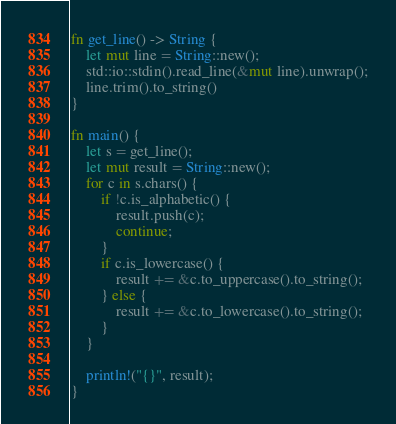Convert code to text. <code><loc_0><loc_0><loc_500><loc_500><_Rust_>fn get_line() -> String {
    let mut line = String::new();
    std::io::stdin().read_line(&mut line).unwrap();
    line.trim().to_string()
}

fn main() {
    let s = get_line();
    let mut result = String::new();
    for c in s.chars() {
        if !c.is_alphabetic() {
            result.push(c);
            continue;
        }
        if c.is_lowercase() {
            result += &c.to_uppercase().to_string();
        } else {
            result += &c.to_lowercase().to_string();
        }
    }

    println!("{}", result);
}

</code> 